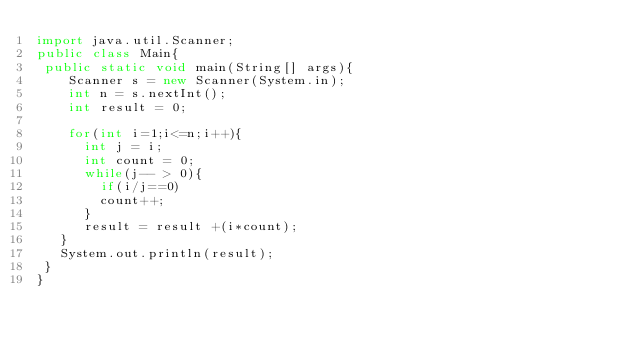<code> <loc_0><loc_0><loc_500><loc_500><_Java_>import java.util.Scanner;
public class Main{
 public static void main(String[] args){
  	Scanner s = new Scanner(System.in);
   	int n = s.nextInt();
   	int result = 0;
   	
   	for(int i=1;i<=n;i++){
      int j = i;
      int count = 0;
      while(j-- > 0){
       	if(i/j==0) 
    		count++;
      }
      result = result +(i*count);
   }
   System.out.println(result);
 }
}
</code> 